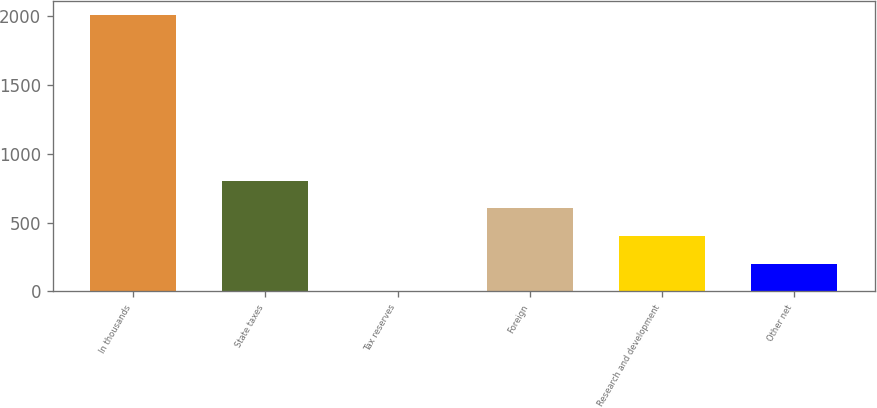Convert chart to OTSL. <chart><loc_0><loc_0><loc_500><loc_500><bar_chart><fcel>In thousands<fcel>State taxes<fcel>Tax reserves<fcel>Foreign<fcel>Research and development<fcel>Other net<nl><fcel>2011<fcel>804.7<fcel>0.5<fcel>603.65<fcel>402.6<fcel>201.55<nl></chart> 